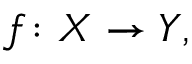<formula> <loc_0><loc_0><loc_500><loc_500>f \colon X \to Y ,</formula> 